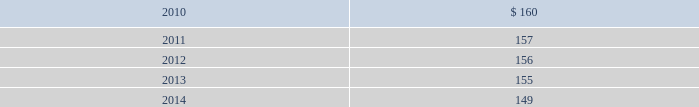Blackrock n 96 n notes in april 2009 , the company acquired $ 2 million of finite- lived management contracts with a five-year estimated useful life associated with the acquisition of the r3 capital partners funds .
In december 2009 , in conjunction with the bgi trans- action , the company acquired $ 163 million of finite- lived management contracts with a weighted-average estimated useful life of approximately 10 years .
Estimated amortization expense for finite-lived intangible assets for each of the five succeeding years is as follows : ( dollar amounts in millions ) .
Indefinite-lived acquired management contracts on september 29 , 2006 , in conjunction with the mlim transaction , the company acquired indefinite-lived man- agement contracts valued at $ 4477 million consisting of $ 4271 million for all retail mutual funds and $ 206 million for alternative investment products .
On october 1 , 2007 , in conjunction with the quellos transaction , the company acquired $ 631 million in indefinite-lived management contracts associated with alternative investment products .
On october 1 , 2007 , the company purchased the remain- ing 20% ( 20 % ) of an investment manager of a fund of hedge funds .
In conjunction with this transaction , the company recorded $ 8 million in additional indefinite-lived management contracts associated with alternative investment products .
On december 1 , 2009 , in conjunction with the bgi transaction , the company acquired $ 9785 million in indefinite-lived management contracts valued consisting primarily for exchange traded funds and common and collective trusts .
Indefinite-lived acquired trade names/trademarks on december 1 , 2009 , in conjunction with the bgi transaction , the company acquired trade names/ trademarks primarily related to ishares valued at $ 1402.5 million .
The fair value was determined using a royalty rate based primarily on normalized marketing and promotion expenditures to develop and support the brands globally .
13 .
Borrowings short-term borrowings 2007 facility in august 2007 , the company entered into a five-year $ 2.5 billion unsecured revolving credit facility ( the 201c2007 facility 201d ) , which permits the company to request an additional $ 500 million of borrowing capacity , subject to lender credit approval , up to a maximum of $ 3.0 billion .
The 2007 facility requires the company not to exceed a maximum leverage ratio ( ratio of net debt to earnings before interest , taxes , depreciation and amortiza- tion , where net debt equals total debt less domestic unrestricted cash ) of 3 to 1 , which was satisfied with a ratio of less than 1 to 1 at december 31 , 2009 .
The 2007 facility provides back-up liquidity , funds ongoing working capital for general corporate purposes and funds various investment opportunities .
At december 31 , 2009 , the company had $ 200 million outstanding under the 2007 facility with an interest rate of 0.44% ( 0.44 % ) and a maturity date during february 2010 .
During february 2010 , the company rolled over $ 100 million in borrowings with an interest rate of 0.43% ( 0.43 % ) and a maturity date in may 2010 .
Lehman commercial paper inc .
Has a $ 140 million participation under the 2007 facility ; however blackrock does not expect that lehman commercial paper inc .
Will honor its commitment to fund additional amounts .
Bank of america , a related party , has a $ 140 million participation under the 2007 facility .
In december 2007 , in order to support two enhanced cash funds that blackrock manages , blackrock elected to procure two letters of credit under the existing 2007 facility in an aggregate amount of $ 100 million .
In decem- ber 2008 , the letters of credit were terminated .
Commercial paper program on october 14 , 2009 , blackrock established a com- mercial paper program ( the 201ccp program 201d ) under which the company may issue unsecured commercial paper notes ( the 201ccp notes 201d ) on a private placement basis up to a maximum aggregate amount outstanding at any time of $ 3 billion .
The proceeds of the commercial paper issuances were used for the financing of a portion of the bgi transaction .
Subsidiaries of bank of america and barclays , as well as other third parties , act as dealers under the cp program .
The cp program is supported by the 2007 facility .
The company began issuance of cp notes under the cp program on november 4 , 2009 .
As of december 31 , 2009 , blackrock had approximately $ 2 billion of out- standing cp notes with a weighted average interest rate of 0.20% ( 0.20 % ) and a weighted average maturity of 23 days .
Since december 31 , 2009 , the company repaid approxi- mately $ 1.4 billion of cp notes with proceeds from the long-term notes issued in december 2009 .
As of march 5 , 2010 , blackrock had $ 596 million of outstanding cp notes with a weighted average interest rate of 0.18% ( 0.18 % ) and a weighted average maturity of 38 days .
Japan commitment-line in june 2008 , blackrock japan co. , ltd. , a wholly owned subsidiary of the company , entered into a five billion japanese yen commitment-line agreement with a bank- ing institution ( the 201cjapan commitment-line 201d ) .
The term of the japan commitment-line was one year and interest accrued at the applicable japanese short-term prime rate .
In june 2009 , blackrock japan co. , ltd .
Renewed the japan commitment-line for a term of one year .
The japan commitment-line is intended to provide liquid- ity and flexibility for operating requirements in japan .
At december 31 , 2009 , the company had no borrowings outstanding on the japan commitment-line .
Convertible debentures in february 2005 , the company issued $ 250 million aggregate principal amount of convertible debentures ( the 201cdebentures 201d ) , due in 2035 and bearing interest at a rate of 2.625% ( 2.625 % ) per annum .
Interest is payable semi- annually in arrears on february 15 and august 15 of each year , and commenced august 15 , 2005 .
Prior to february 15 , 2009 , the debentures could have been convertible at the option of the holder at a decem- ber 31 , 2008 conversion rate of 9.9639 shares of common stock per one dollar principal amount of debentures under certain circumstances .
The debentures would have been convertible into cash and , in some situations as described below , additional shares of the company 2019s common stock , if during the five business day period after any five consecutive trading day period the trading price per debenture for each day of such period is less than 103% ( 103 % ) of the product of the last reported sales price of blackrock 2019s common stock and the conversion rate of the debentures on each such day or upon the occurrence of certain other corporate events , such as a distribution to the holders of blackrock common stock of certain rights , assets or debt securities , if the company becomes party to a merger , consolidation or transfer of all or substantially all of its assets or a change of control of the company .
On february 15 , 2009 , the debentures became convertible into cash at any time prior to maturity at the option of the holder and , in some situations as described below , additional shares of the company 2019s common stock at the current conversion rate .
At the time the debentures are tendered for conver- sion , for each one dollar principal amount of debentures converted , a holder shall be entitled to receive cash and shares of blackrock common stock , if any , the aggregate value of which ( the 201cconversion value 201d ) will be deter- mined by multiplying the applicable conversion rate by the average of the daily volume weighted average price of blackrock common stock for each of the ten consecutive trading days beginning on the second trading day imme- diately following the day the debentures are tendered for conversion ( the 201cten-day weighted average price 201d ) .
The company will deliver the conversion value to holders as follows : ( 1 ) an amount in cash ( the 201cprincipal return 201d ) equal to the lesser of ( a ) the aggregate conversion value of the debentures to be converted and ( b ) the aggregate principal amount of the debentures to be converted , and ( 2 ) if the aggregate conversion value of the debentures to be converted is greater than the principal return , an amount in shares ( the 201cnet shares 201d ) , determined as set forth below , equal to such aggregate conversion value less the principal return ( the 201cnet share amount 201d ) .
The number of net shares to be paid will be determined by dividing the net share amount by the ten-day weighted average price .
In lieu of delivering fractional shares , the company will deliver cash based on the ten-day weighted average price .
The conversion rate for the debentures is subject to adjustments upon the occurrence of certain corporate events , such as a change of control of the company , 193253ti_txt.indd 96 4/2/10 1:18 pm .
What is the annual amortization expense related to bgi transaction of 2009 under a straight-line amortization method , in millions? 
Computations: (163 / 10)
Answer: 16.3. 